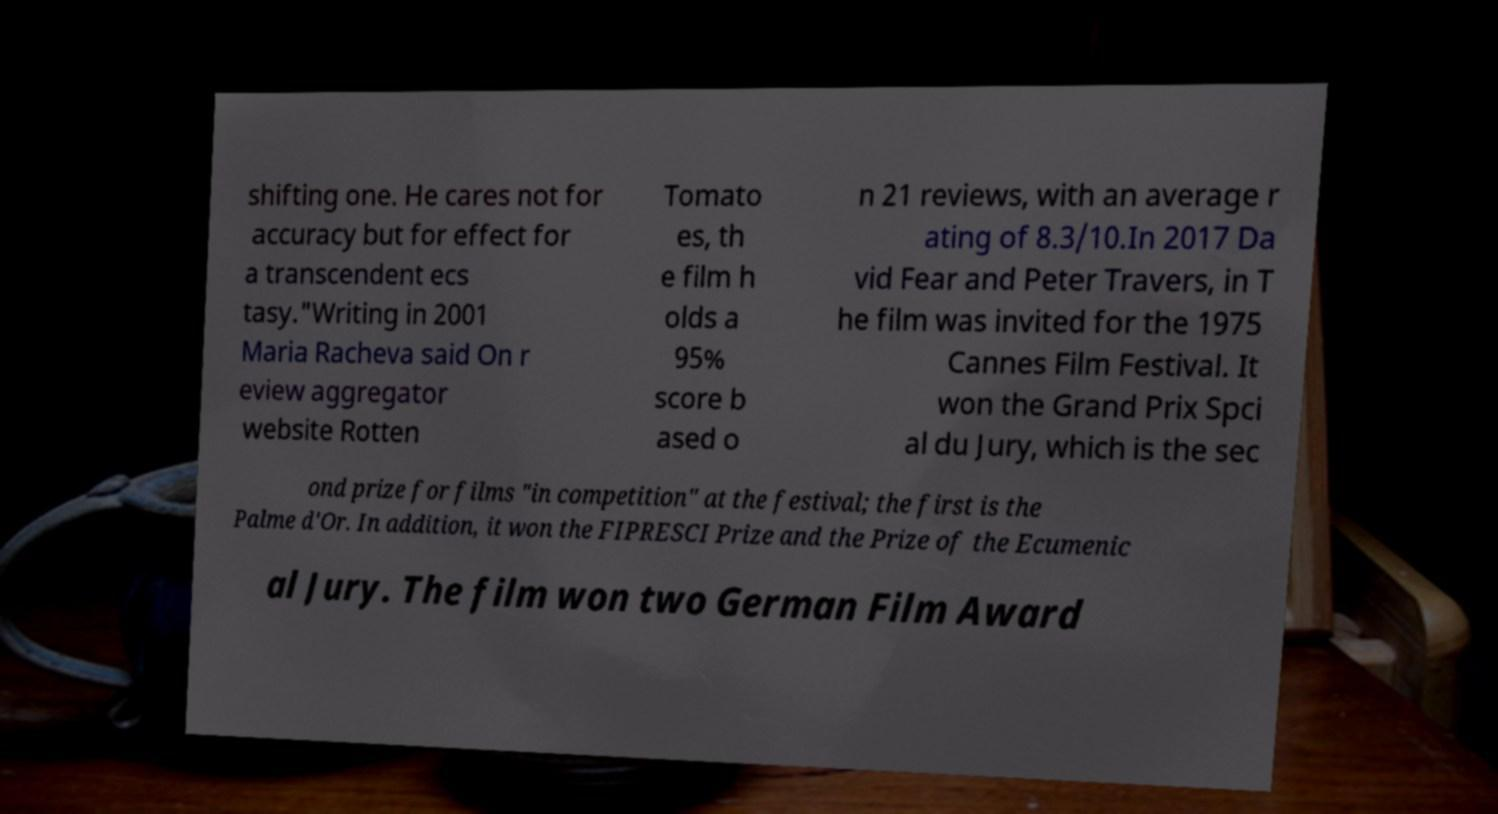I need the written content from this picture converted into text. Can you do that? shifting one. He cares not for accuracy but for effect for a transcendent ecs tasy."Writing in 2001 Maria Racheva said On r eview aggregator website Rotten Tomato es, th e film h olds a 95% score b ased o n 21 reviews, with an average r ating of 8.3/10.In 2017 Da vid Fear and Peter Travers, in T he film was invited for the 1975 Cannes Film Festival. It won the Grand Prix Spci al du Jury, which is the sec ond prize for films "in competition" at the festival; the first is the Palme d'Or. In addition, it won the FIPRESCI Prize and the Prize of the Ecumenic al Jury. The film won two German Film Award 